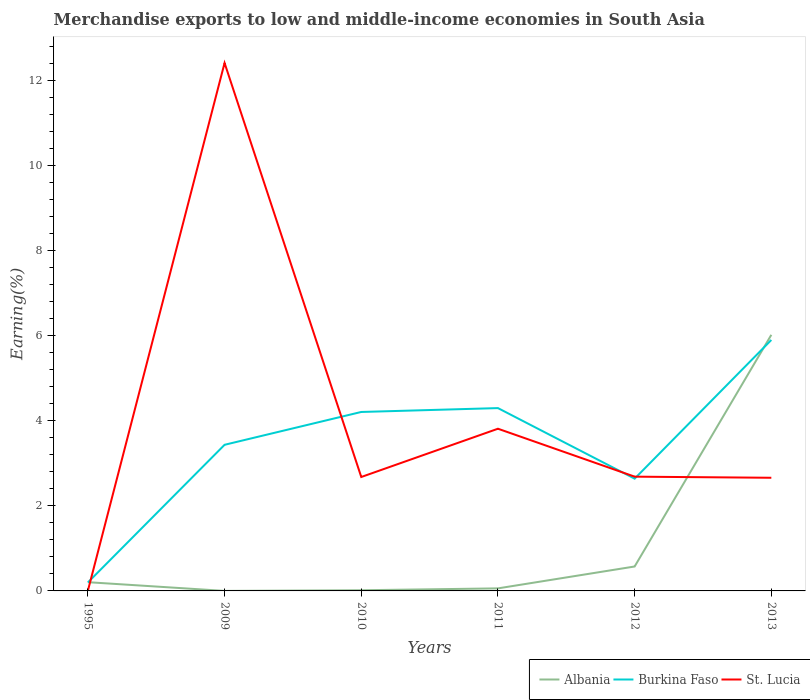Does the line corresponding to Burkina Faso intersect with the line corresponding to St. Lucia?
Provide a succinct answer. Yes. Is the number of lines equal to the number of legend labels?
Offer a very short reply. Yes. Across all years, what is the maximum percentage of amount earned from merchandise exports in Albania?
Ensure brevity in your answer.  0. What is the total percentage of amount earned from merchandise exports in St. Lucia in the graph?
Offer a very short reply. -1.13. What is the difference between the highest and the second highest percentage of amount earned from merchandise exports in Burkina Faso?
Give a very brief answer. 5.7. What is the difference between the highest and the lowest percentage of amount earned from merchandise exports in Burkina Faso?
Offer a very short reply. 3. How many lines are there?
Offer a terse response. 3. How many years are there in the graph?
Provide a short and direct response. 6. What is the difference between two consecutive major ticks on the Y-axis?
Make the answer very short. 2. Where does the legend appear in the graph?
Provide a succinct answer. Bottom right. How are the legend labels stacked?
Keep it short and to the point. Horizontal. What is the title of the graph?
Provide a succinct answer. Merchandise exports to low and middle-income economies in South Asia. What is the label or title of the X-axis?
Provide a succinct answer. Years. What is the label or title of the Y-axis?
Give a very brief answer. Earning(%). What is the Earning(%) in Albania in 1995?
Keep it short and to the point. 0.21. What is the Earning(%) in Burkina Faso in 1995?
Offer a very short reply. 0.2. What is the Earning(%) of St. Lucia in 1995?
Give a very brief answer. 0. What is the Earning(%) of Albania in 2009?
Offer a terse response. 0. What is the Earning(%) of Burkina Faso in 2009?
Keep it short and to the point. 3.43. What is the Earning(%) in St. Lucia in 2009?
Make the answer very short. 12.4. What is the Earning(%) of Albania in 2010?
Offer a very short reply. 0.02. What is the Earning(%) of Burkina Faso in 2010?
Offer a very short reply. 4.2. What is the Earning(%) of St. Lucia in 2010?
Your response must be concise. 2.68. What is the Earning(%) of Albania in 2011?
Provide a succinct answer. 0.06. What is the Earning(%) in Burkina Faso in 2011?
Provide a succinct answer. 4.3. What is the Earning(%) of St. Lucia in 2011?
Provide a succinct answer. 3.81. What is the Earning(%) in Albania in 2012?
Make the answer very short. 0.57. What is the Earning(%) of Burkina Faso in 2012?
Make the answer very short. 2.64. What is the Earning(%) of St. Lucia in 2012?
Your answer should be compact. 2.68. What is the Earning(%) in Albania in 2013?
Provide a short and direct response. 6.02. What is the Earning(%) in Burkina Faso in 2013?
Keep it short and to the point. 5.9. What is the Earning(%) of St. Lucia in 2013?
Make the answer very short. 2.66. Across all years, what is the maximum Earning(%) in Albania?
Provide a succinct answer. 6.02. Across all years, what is the maximum Earning(%) of Burkina Faso?
Provide a succinct answer. 5.9. Across all years, what is the maximum Earning(%) in St. Lucia?
Offer a very short reply. 12.4. Across all years, what is the minimum Earning(%) of Albania?
Make the answer very short. 0. Across all years, what is the minimum Earning(%) of Burkina Faso?
Provide a short and direct response. 0.2. Across all years, what is the minimum Earning(%) in St. Lucia?
Ensure brevity in your answer.  0. What is the total Earning(%) in Albania in the graph?
Offer a terse response. 6.87. What is the total Earning(%) in Burkina Faso in the graph?
Keep it short and to the point. 20.67. What is the total Earning(%) in St. Lucia in the graph?
Your answer should be compact. 24.24. What is the difference between the Earning(%) in Albania in 1995 and that in 2009?
Ensure brevity in your answer.  0.2. What is the difference between the Earning(%) in Burkina Faso in 1995 and that in 2009?
Offer a terse response. -3.23. What is the difference between the Earning(%) in St. Lucia in 1995 and that in 2009?
Your answer should be very brief. -12.4. What is the difference between the Earning(%) in Albania in 1995 and that in 2010?
Provide a short and direct response. 0.19. What is the difference between the Earning(%) of Burkina Faso in 1995 and that in 2010?
Provide a short and direct response. -4.01. What is the difference between the Earning(%) of St. Lucia in 1995 and that in 2010?
Give a very brief answer. -2.67. What is the difference between the Earning(%) of Albania in 1995 and that in 2011?
Provide a succinct answer. 0.15. What is the difference between the Earning(%) of Burkina Faso in 1995 and that in 2011?
Provide a short and direct response. -4.1. What is the difference between the Earning(%) in St. Lucia in 1995 and that in 2011?
Offer a terse response. -3.81. What is the difference between the Earning(%) of Albania in 1995 and that in 2012?
Provide a short and direct response. -0.37. What is the difference between the Earning(%) of Burkina Faso in 1995 and that in 2012?
Your answer should be compact. -2.44. What is the difference between the Earning(%) of St. Lucia in 1995 and that in 2012?
Ensure brevity in your answer.  -2.68. What is the difference between the Earning(%) of Albania in 1995 and that in 2013?
Make the answer very short. -5.81. What is the difference between the Earning(%) in Burkina Faso in 1995 and that in 2013?
Provide a short and direct response. -5.7. What is the difference between the Earning(%) of St. Lucia in 1995 and that in 2013?
Keep it short and to the point. -2.65. What is the difference between the Earning(%) in Albania in 2009 and that in 2010?
Make the answer very short. -0.02. What is the difference between the Earning(%) of Burkina Faso in 2009 and that in 2010?
Ensure brevity in your answer.  -0.77. What is the difference between the Earning(%) of St. Lucia in 2009 and that in 2010?
Make the answer very short. 9.73. What is the difference between the Earning(%) in Albania in 2009 and that in 2011?
Keep it short and to the point. -0.06. What is the difference between the Earning(%) of Burkina Faso in 2009 and that in 2011?
Make the answer very short. -0.86. What is the difference between the Earning(%) in St. Lucia in 2009 and that in 2011?
Make the answer very short. 8.59. What is the difference between the Earning(%) in Albania in 2009 and that in 2012?
Ensure brevity in your answer.  -0.57. What is the difference between the Earning(%) of Burkina Faso in 2009 and that in 2012?
Your answer should be very brief. 0.8. What is the difference between the Earning(%) of St. Lucia in 2009 and that in 2012?
Your answer should be very brief. 9.72. What is the difference between the Earning(%) of Albania in 2009 and that in 2013?
Your answer should be compact. -6.02. What is the difference between the Earning(%) in Burkina Faso in 2009 and that in 2013?
Your response must be concise. -2.46. What is the difference between the Earning(%) in St. Lucia in 2009 and that in 2013?
Ensure brevity in your answer.  9.75. What is the difference between the Earning(%) of Albania in 2010 and that in 2011?
Offer a very short reply. -0.04. What is the difference between the Earning(%) of Burkina Faso in 2010 and that in 2011?
Your answer should be very brief. -0.09. What is the difference between the Earning(%) of St. Lucia in 2010 and that in 2011?
Make the answer very short. -1.13. What is the difference between the Earning(%) of Albania in 2010 and that in 2012?
Your answer should be compact. -0.56. What is the difference between the Earning(%) of Burkina Faso in 2010 and that in 2012?
Provide a succinct answer. 1.57. What is the difference between the Earning(%) of St. Lucia in 2010 and that in 2012?
Offer a terse response. -0.01. What is the difference between the Earning(%) of Albania in 2010 and that in 2013?
Give a very brief answer. -6. What is the difference between the Earning(%) in Burkina Faso in 2010 and that in 2013?
Provide a succinct answer. -1.69. What is the difference between the Earning(%) in St. Lucia in 2010 and that in 2013?
Provide a short and direct response. 0.02. What is the difference between the Earning(%) of Albania in 2011 and that in 2012?
Give a very brief answer. -0.51. What is the difference between the Earning(%) in Burkina Faso in 2011 and that in 2012?
Your answer should be very brief. 1.66. What is the difference between the Earning(%) in St. Lucia in 2011 and that in 2012?
Make the answer very short. 1.13. What is the difference between the Earning(%) of Albania in 2011 and that in 2013?
Your answer should be compact. -5.96. What is the difference between the Earning(%) in Burkina Faso in 2011 and that in 2013?
Ensure brevity in your answer.  -1.6. What is the difference between the Earning(%) of St. Lucia in 2011 and that in 2013?
Your answer should be very brief. 1.15. What is the difference between the Earning(%) in Albania in 2012 and that in 2013?
Offer a very short reply. -5.44. What is the difference between the Earning(%) of Burkina Faso in 2012 and that in 2013?
Your answer should be compact. -3.26. What is the difference between the Earning(%) of St. Lucia in 2012 and that in 2013?
Your answer should be compact. 0.03. What is the difference between the Earning(%) of Albania in 1995 and the Earning(%) of Burkina Faso in 2009?
Your answer should be very brief. -3.23. What is the difference between the Earning(%) of Albania in 1995 and the Earning(%) of St. Lucia in 2009?
Ensure brevity in your answer.  -12.2. What is the difference between the Earning(%) in Burkina Faso in 1995 and the Earning(%) in St. Lucia in 2009?
Ensure brevity in your answer.  -12.2. What is the difference between the Earning(%) in Albania in 1995 and the Earning(%) in Burkina Faso in 2010?
Your answer should be compact. -4. What is the difference between the Earning(%) in Albania in 1995 and the Earning(%) in St. Lucia in 2010?
Ensure brevity in your answer.  -2.47. What is the difference between the Earning(%) in Burkina Faso in 1995 and the Earning(%) in St. Lucia in 2010?
Provide a short and direct response. -2.48. What is the difference between the Earning(%) in Albania in 1995 and the Earning(%) in Burkina Faso in 2011?
Provide a short and direct response. -4.09. What is the difference between the Earning(%) of Albania in 1995 and the Earning(%) of St. Lucia in 2011?
Give a very brief answer. -3.61. What is the difference between the Earning(%) in Burkina Faso in 1995 and the Earning(%) in St. Lucia in 2011?
Your response must be concise. -3.61. What is the difference between the Earning(%) of Albania in 1995 and the Earning(%) of Burkina Faso in 2012?
Your response must be concise. -2.43. What is the difference between the Earning(%) in Albania in 1995 and the Earning(%) in St. Lucia in 2012?
Provide a succinct answer. -2.48. What is the difference between the Earning(%) of Burkina Faso in 1995 and the Earning(%) of St. Lucia in 2012?
Provide a succinct answer. -2.49. What is the difference between the Earning(%) of Albania in 1995 and the Earning(%) of Burkina Faso in 2013?
Provide a succinct answer. -5.69. What is the difference between the Earning(%) of Albania in 1995 and the Earning(%) of St. Lucia in 2013?
Offer a terse response. -2.45. What is the difference between the Earning(%) in Burkina Faso in 1995 and the Earning(%) in St. Lucia in 2013?
Ensure brevity in your answer.  -2.46. What is the difference between the Earning(%) of Albania in 2009 and the Earning(%) of Burkina Faso in 2010?
Keep it short and to the point. -4.2. What is the difference between the Earning(%) of Albania in 2009 and the Earning(%) of St. Lucia in 2010?
Give a very brief answer. -2.68. What is the difference between the Earning(%) of Burkina Faso in 2009 and the Earning(%) of St. Lucia in 2010?
Your answer should be compact. 0.76. What is the difference between the Earning(%) of Albania in 2009 and the Earning(%) of Burkina Faso in 2011?
Your answer should be compact. -4.29. What is the difference between the Earning(%) of Albania in 2009 and the Earning(%) of St. Lucia in 2011?
Provide a succinct answer. -3.81. What is the difference between the Earning(%) of Burkina Faso in 2009 and the Earning(%) of St. Lucia in 2011?
Ensure brevity in your answer.  -0.38. What is the difference between the Earning(%) in Albania in 2009 and the Earning(%) in Burkina Faso in 2012?
Your answer should be very brief. -2.64. What is the difference between the Earning(%) in Albania in 2009 and the Earning(%) in St. Lucia in 2012?
Your answer should be compact. -2.68. What is the difference between the Earning(%) of Burkina Faso in 2009 and the Earning(%) of St. Lucia in 2012?
Offer a very short reply. 0.75. What is the difference between the Earning(%) of Albania in 2009 and the Earning(%) of Burkina Faso in 2013?
Provide a succinct answer. -5.9. What is the difference between the Earning(%) of Albania in 2009 and the Earning(%) of St. Lucia in 2013?
Ensure brevity in your answer.  -2.66. What is the difference between the Earning(%) of Burkina Faso in 2009 and the Earning(%) of St. Lucia in 2013?
Give a very brief answer. 0.77. What is the difference between the Earning(%) of Albania in 2010 and the Earning(%) of Burkina Faso in 2011?
Provide a succinct answer. -4.28. What is the difference between the Earning(%) of Albania in 2010 and the Earning(%) of St. Lucia in 2011?
Provide a short and direct response. -3.79. What is the difference between the Earning(%) in Burkina Faso in 2010 and the Earning(%) in St. Lucia in 2011?
Your answer should be compact. 0.39. What is the difference between the Earning(%) of Albania in 2010 and the Earning(%) of Burkina Faso in 2012?
Offer a very short reply. -2.62. What is the difference between the Earning(%) in Albania in 2010 and the Earning(%) in St. Lucia in 2012?
Offer a very short reply. -2.67. What is the difference between the Earning(%) of Burkina Faso in 2010 and the Earning(%) of St. Lucia in 2012?
Ensure brevity in your answer.  1.52. What is the difference between the Earning(%) in Albania in 2010 and the Earning(%) in Burkina Faso in 2013?
Provide a short and direct response. -5.88. What is the difference between the Earning(%) of Albania in 2010 and the Earning(%) of St. Lucia in 2013?
Make the answer very short. -2.64. What is the difference between the Earning(%) in Burkina Faso in 2010 and the Earning(%) in St. Lucia in 2013?
Your answer should be very brief. 1.55. What is the difference between the Earning(%) in Albania in 2011 and the Earning(%) in Burkina Faso in 2012?
Offer a terse response. -2.58. What is the difference between the Earning(%) of Albania in 2011 and the Earning(%) of St. Lucia in 2012?
Offer a very short reply. -2.62. What is the difference between the Earning(%) of Burkina Faso in 2011 and the Earning(%) of St. Lucia in 2012?
Provide a short and direct response. 1.61. What is the difference between the Earning(%) in Albania in 2011 and the Earning(%) in Burkina Faso in 2013?
Give a very brief answer. -5.84. What is the difference between the Earning(%) of Albania in 2011 and the Earning(%) of St. Lucia in 2013?
Offer a terse response. -2.6. What is the difference between the Earning(%) of Burkina Faso in 2011 and the Earning(%) of St. Lucia in 2013?
Provide a succinct answer. 1.64. What is the difference between the Earning(%) in Albania in 2012 and the Earning(%) in Burkina Faso in 2013?
Keep it short and to the point. -5.32. What is the difference between the Earning(%) in Albania in 2012 and the Earning(%) in St. Lucia in 2013?
Make the answer very short. -2.08. What is the difference between the Earning(%) of Burkina Faso in 2012 and the Earning(%) of St. Lucia in 2013?
Provide a short and direct response. -0.02. What is the average Earning(%) of Albania per year?
Your response must be concise. 1.15. What is the average Earning(%) in Burkina Faso per year?
Provide a short and direct response. 3.44. What is the average Earning(%) in St. Lucia per year?
Provide a succinct answer. 4.04. In the year 1995, what is the difference between the Earning(%) in Albania and Earning(%) in Burkina Faso?
Offer a terse response. 0.01. In the year 1995, what is the difference between the Earning(%) of Albania and Earning(%) of St. Lucia?
Keep it short and to the point. 0.2. In the year 1995, what is the difference between the Earning(%) in Burkina Faso and Earning(%) in St. Lucia?
Provide a succinct answer. 0.19. In the year 2009, what is the difference between the Earning(%) in Albania and Earning(%) in Burkina Faso?
Give a very brief answer. -3.43. In the year 2009, what is the difference between the Earning(%) of Albania and Earning(%) of St. Lucia?
Your response must be concise. -12.4. In the year 2009, what is the difference between the Earning(%) of Burkina Faso and Earning(%) of St. Lucia?
Give a very brief answer. -8.97. In the year 2010, what is the difference between the Earning(%) of Albania and Earning(%) of Burkina Faso?
Offer a terse response. -4.19. In the year 2010, what is the difference between the Earning(%) in Albania and Earning(%) in St. Lucia?
Provide a short and direct response. -2.66. In the year 2010, what is the difference between the Earning(%) in Burkina Faso and Earning(%) in St. Lucia?
Ensure brevity in your answer.  1.53. In the year 2011, what is the difference between the Earning(%) in Albania and Earning(%) in Burkina Faso?
Offer a terse response. -4.24. In the year 2011, what is the difference between the Earning(%) in Albania and Earning(%) in St. Lucia?
Offer a very short reply. -3.75. In the year 2011, what is the difference between the Earning(%) of Burkina Faso and Earning(%) of St. Lucia?
Your response must be concise. 0.48. In the year 2012, what is the difference between the Earning(%) in Albania and Earning(%) in Burkina Faso?
Ensure brevity in your answer.  -2.06. In the year 2012, what is the difference between the Earning(%) of Albania and Earning(%) of St. Lucia?
Provide a short and direct response. -2.11. In the year 2012, what is the difference between the Earning(%) of Burkina Faso and Earning(%) of St. Lucia?
Make the answer very short. -0.05. In the year 2013, what is the difference between the Earning(%) of Albania and Earning(%) of Burkina Faso?
Keep it short and to the point. 0.12. In the year 2013, what is the difference between the Earning(%) in Albania and Earning(%) in St. Lucia?
Offer a terse response. 3.36. In the year 2013, what is the difference between the Earning(%) in Burkina Faso and Earning(%) in St. Lucia?
Your response must be concise. 3.24. What is the ratio of the Earning(%) in Albania in 1995 to that in 2009?
Provide a short and direct response. 373.57. What is the ratio of the Earning(%) in Burkina Faso in 1995 to that in 2009?
Give a very brief answer. 0.06. What is the ratio of the Earning(%) of St. Lucia in 1995 to that in 2009?
Keep it short and to the point. 0. What is the ratio of the Earning(%) in Albania in 1995 to that in 2010?
Offer a very short reply. 12.87. What is the ratio of the Earning(%) of Burkina Faso in 1995 to that in 2010?
Make the answer very short. 0.05. What is the ratio of the Earning(%) in St. Lucia in 1995 to that in 2010?
Provide a succinct answer. 0. What is the ratio of the Earning(%) in Albania in 1995 to that in 2011?
Provide a short and direct response. 3.43. What is the ratio of the Earning(%) in Burkina Faso in 1995 to that in 2011?
Provide a succinct answer. 0.05. What is the ratio of the Earning(%) of St. Lucia in 1995 to that in 2011?
Provide a succinct answer. 0. What is the ratio of the Earning(%) of Albania in 1995 to that in 2012?
Offer a very short reply. 0.36. What is the ratio of the Earning(%) in Burkina Faso in 1995 to that in 2012?
Make the answer very short. 0.08. What is the ratio of the Earning(%) of St. Lucia in 1995 to that in 2012?
Your response must be concise. 0. What is the ratio of the Earning(%) in Albania in 1995 to that in 2013?
Offer a very short reply. 0.03. What is the ratio of the Earning(%) in Burkina Faso in 1995 to that in 2013?
Give a very brief answer. 0.03. What is the ratio of the Earning(%) in St. Lucia in 1995 to that in 2013?
Make the answer very short. 0. What is the ratio of the Earning(%) of Albania in 2009 to that in 2010?
Offer a terse response. 0.03. What is the ratio of the Earning(%) of Burkina Faso in 2009 to that in 2010?
Your answer should be compact. 0.82. What is the ratio of the Earning(%) in St. Lucia in 2009 to that in 2010?
Keep it short and to the point. 4.63. What is the ratio of the Earning(%) in Albania in 2009 to that in 2011?
Offer a terse response. 0.01. What is the ratio of the Earning(%) in Burkina Faso in 2009 to that in 2011?
Offer a very short reply. 0.8. What is the ratio of the Earning(%) in St. Lucia in 2009 to that in 2011?
Offer a very short reply. 3.26. What is the ratio of the Earning(%) in Burkina Faso in 2009 to that in 2012?
Your response must be concise. 1.3. What is the ratio of the Earning(%) in St. Lucia in 2009 to that in 2012?
Provide a short and direct response. 4.62. What is the ratio of the Earning(%) of Burkina Faso in 2009 to that in 2013?
Provide a short and direct response. 0.58. What is the ratio of the Earning(%) in St. Lucia in 2009 to that in 2013?
Offer a terse response. 4.67. What is the ratio of the Earning(%) in Albania in 2010 to that in 2011?
Make the answer very short. 0.27. What is the ratio of the Earning(%) of Burkina Faso in 2010 to that in 2011?
Your response must be concise. 0.98. What is the ratio of the Earning(%) in St. Lucia in 2010 to that in 2011?
Your response must be concise. 0.7. What is the ratio of the Earning(%) of Albania in 2010 to that in 2012?
Offer a very short reply. 0.03. What is the ratio of the Earning(%) of Burkina Faso in 2010 to that in 2012?
Offer a terse response. 1.59. What is the ratio of the Earning(%) in St. Lucia in 2010 to that in 2012?
Your response must be concise. 1. What is the ratio of the Earning(%) in Albania in 2010 to that in 2013?
Offer a very short reply. 0. What is the ratio of the Earning(%) of Burkina Faso in 2010 to that in 2013?
Provide a short and direct response. 0.71. What is the ratio of the Earning(%) in St. Lucia in 2010 to that in 2013?
Make the answer very short. 1.01. What is the ratio of the Earning(%) in Albania in 2011 to that in 2012?
Provide a succinct answer. 0.1. What is the ratio of the Earning(%) of Burkina Faso in 2011 to that in 2012?
Provide a succinct answer. 1.63. What is the ratio of the Earning(%) in St. Lucia in 2011 to that in 2012?
Provide a succinct answer. 1.42. What is the ratio of the Earning(%) in Albania in 2011 to that in 2013?
Make the answer very short. 0.01. What is the ratio of the Earning(%) in Burkina Faso in 2011 to that in 2013?
Offer a terse response. 0.73. What is the ratio of the Earning(%) in St. Lucia in 2011 to that in 2013?
Provide a succinct answer. 1.43. What is the ratio of the Earning(%) of Albania in 2012 to that in 2013?
Provide a succinct answer. 0.1. What is the ratio of the Earning(%) of Burkina Faso in 2012 to that in 2013?
Offer a very short reply. 0.45. What is the ratio of the Earning(%) in St. Lucia in 2012 to that in 2013?
Keep it short and to the point. 1.01. What is the difference between the highest and the second highest Earning(%) of Albania?
Offer a very short reply. 5.44. What is the difference between the highest and the second highest Earning(%) in Burkina Faso?
Your response must be concise. 1.6. What is the difference between the highest and the second highest Earning(%) of St. Lucia?
Your answer should be very brief. 8.59. What is the difference between the highest and the lowest Earning(%) of Albania?
Provide a succinct answer. 6.02. What is the difference between the highest and the lowest Earning(%) in Burkina Faso?
Offer a very short reply. 5.7. What is the difference between the highest and the lowest Earning(%) of St. Lucia?
Offer a very short reply. 12.4. 